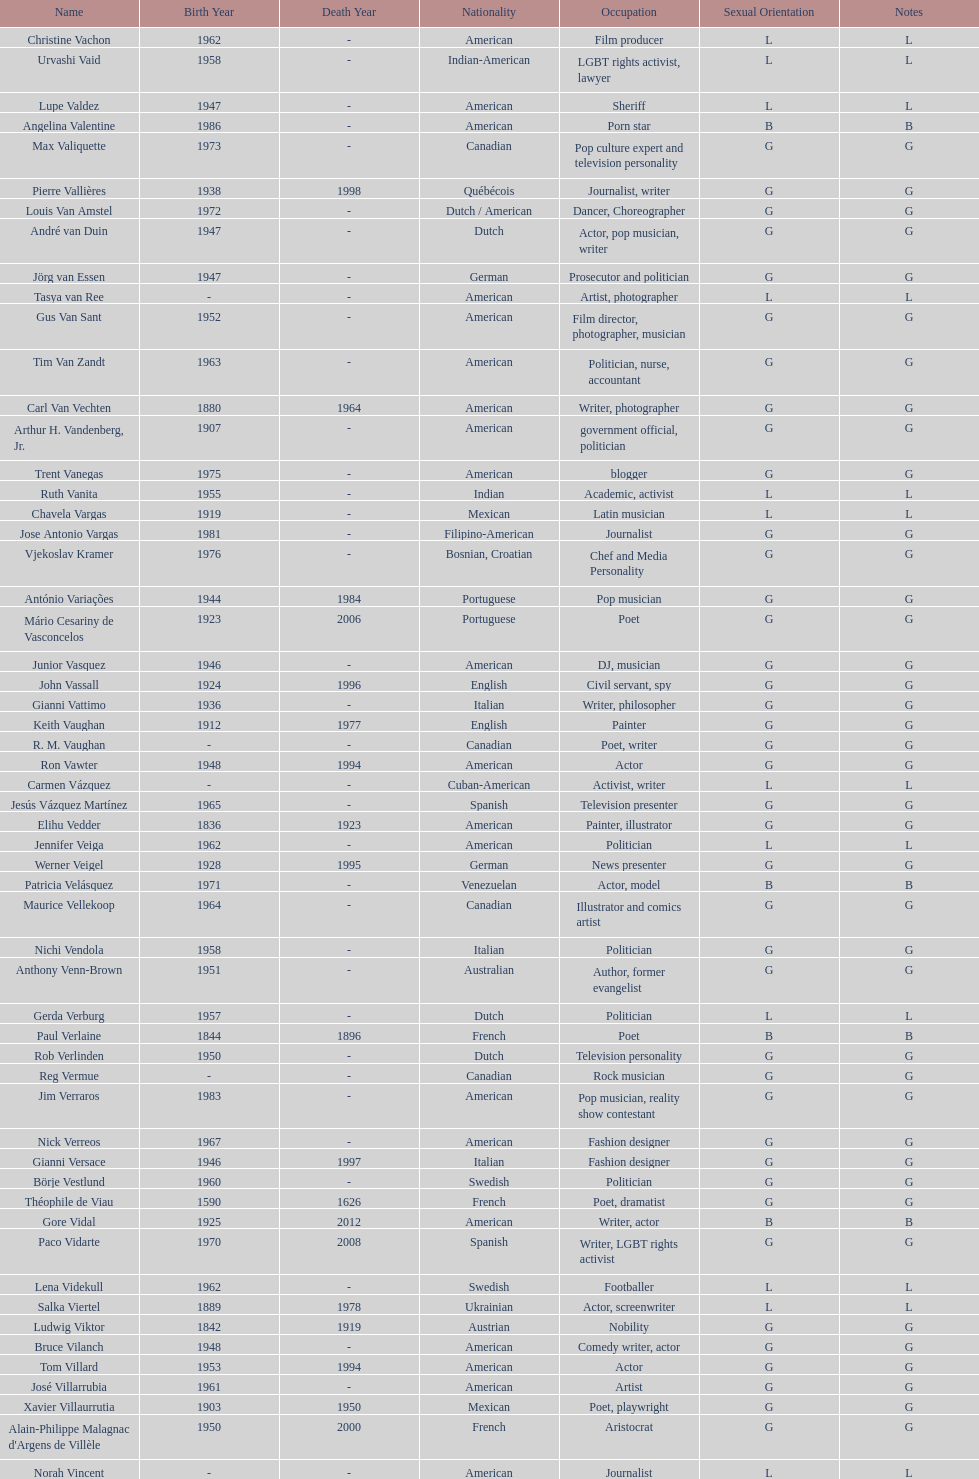How old was pierre vallieres before he died? 60. 